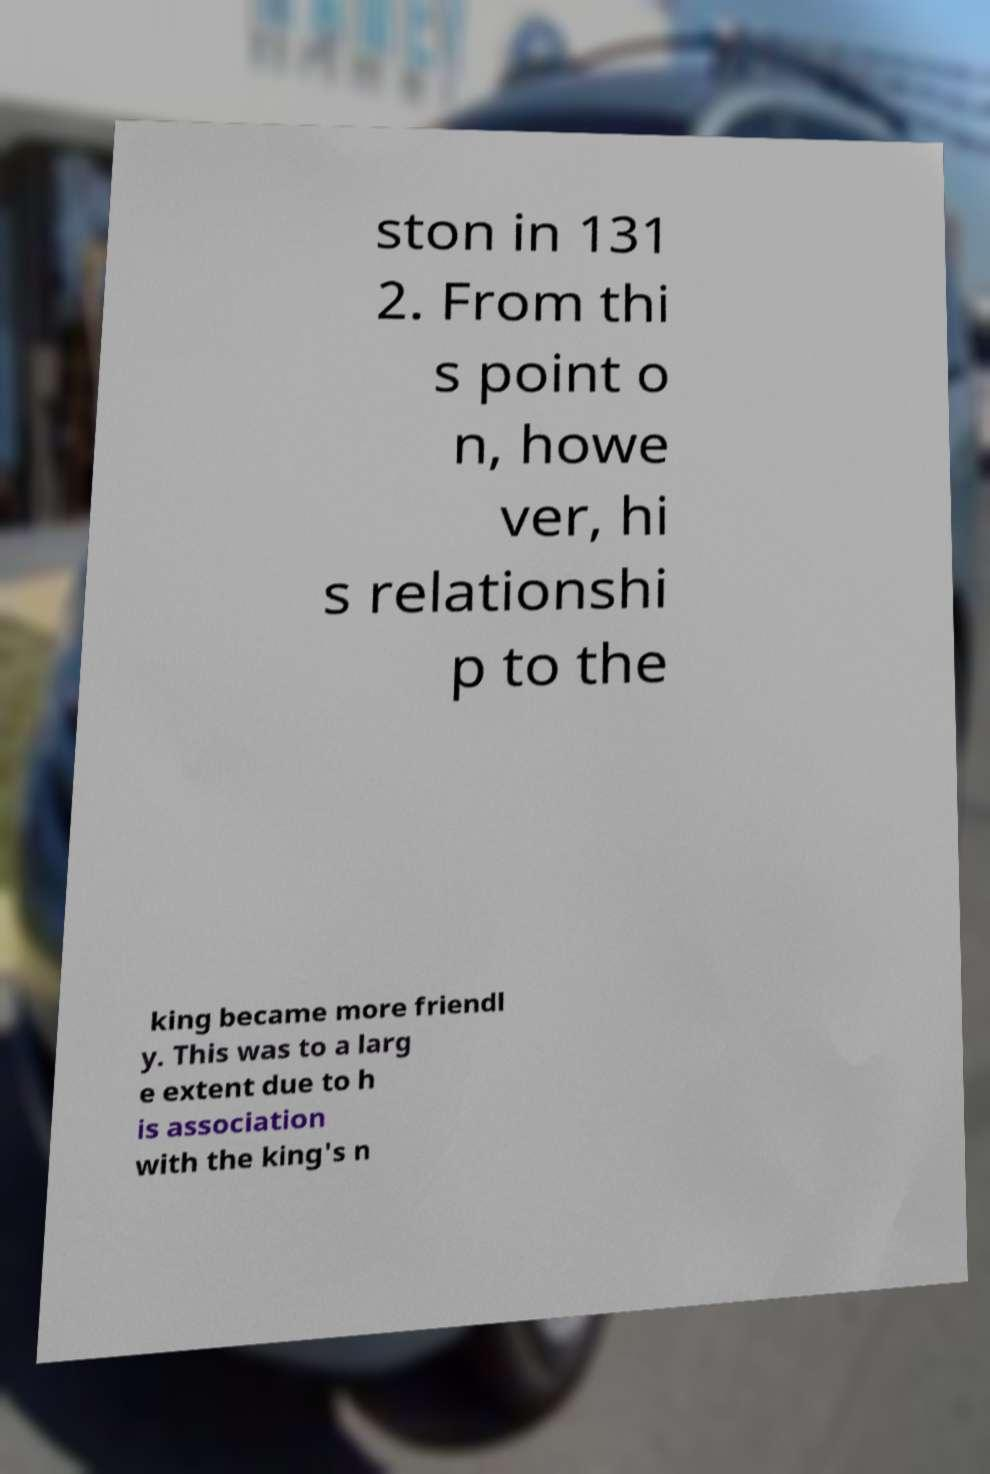Please read and relay the text visible in this image. What does it say? ston in 131 2. From thi s point o n, howe ver, hi s relationshi p to the king became more friendl y. This was to a larg e extent due to h is association with the king's n 